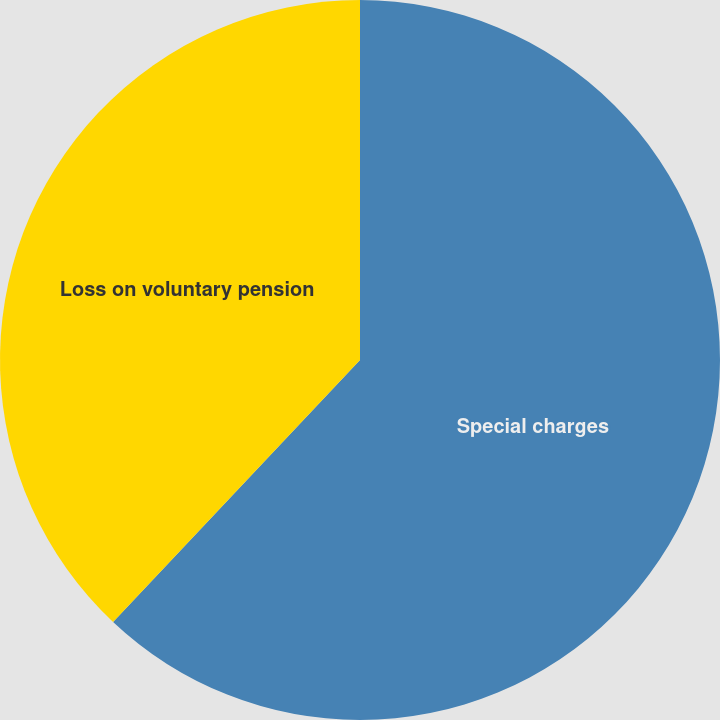<chart> <loc_0><loc_0><loc_500><loc_500><pie_chart><fcel>Special charges<fcel>Loss on voluntary pension<nl><fcel>62.03%<fcel>37.97%<nl></chart> 